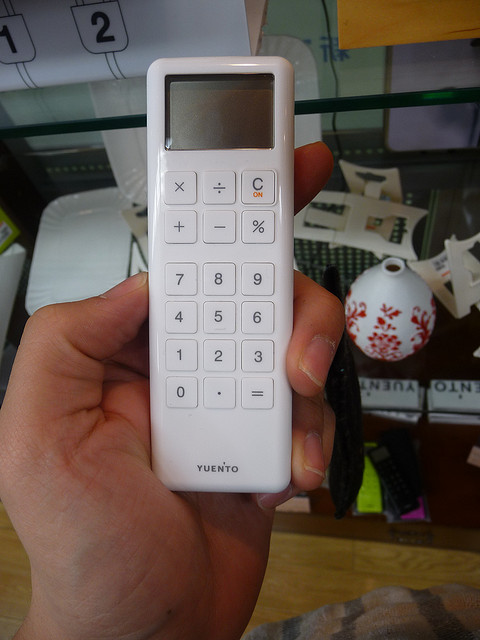Identify the text displayed in this image. YUENTO 7 8 9 6 1 2 YUENY 0 3 2 1 4 5 C 